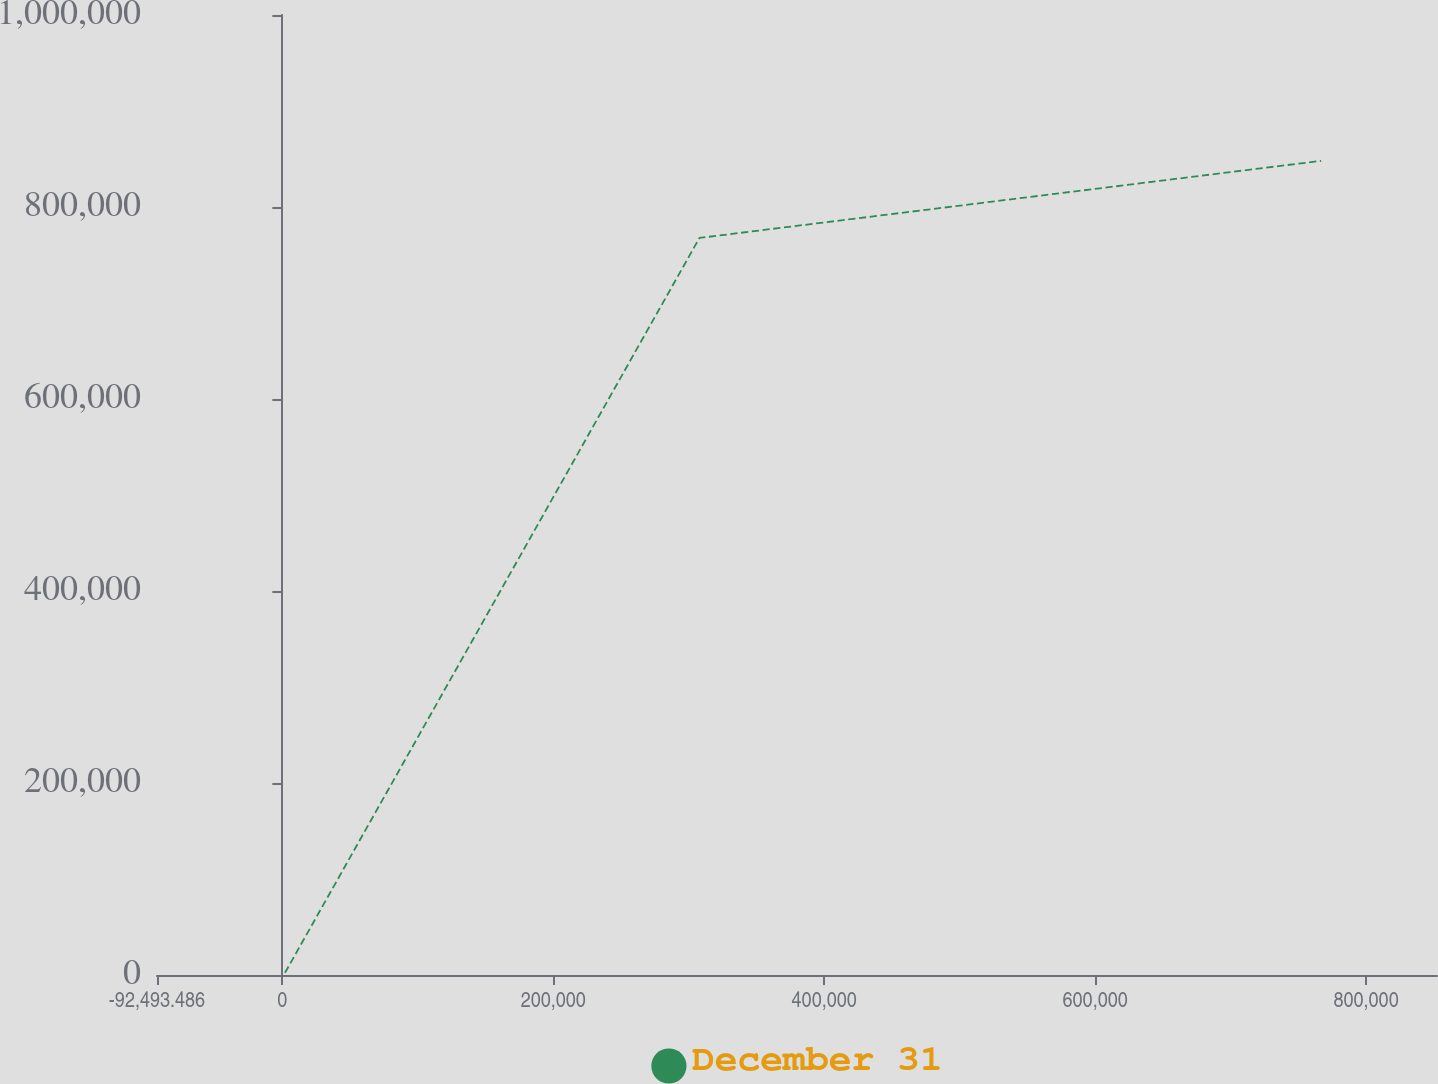Convert chart to OTSL. <chart><loc_0><loc_0><loc_500><loc_500><line_chart><ecel><fcel>December 31<nl><fcel>1990.71<fcel>2340.35<nl><fcel>307943<fcel>767809<nl><fcel>766808<fcel>848069<nl><fcel>946833<fcel>310881<nl></chart> 